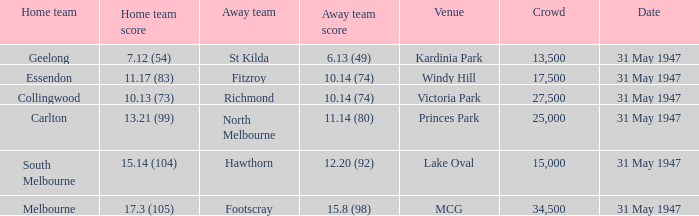What is the listed crowd when hawthorn is away? 1.0. 